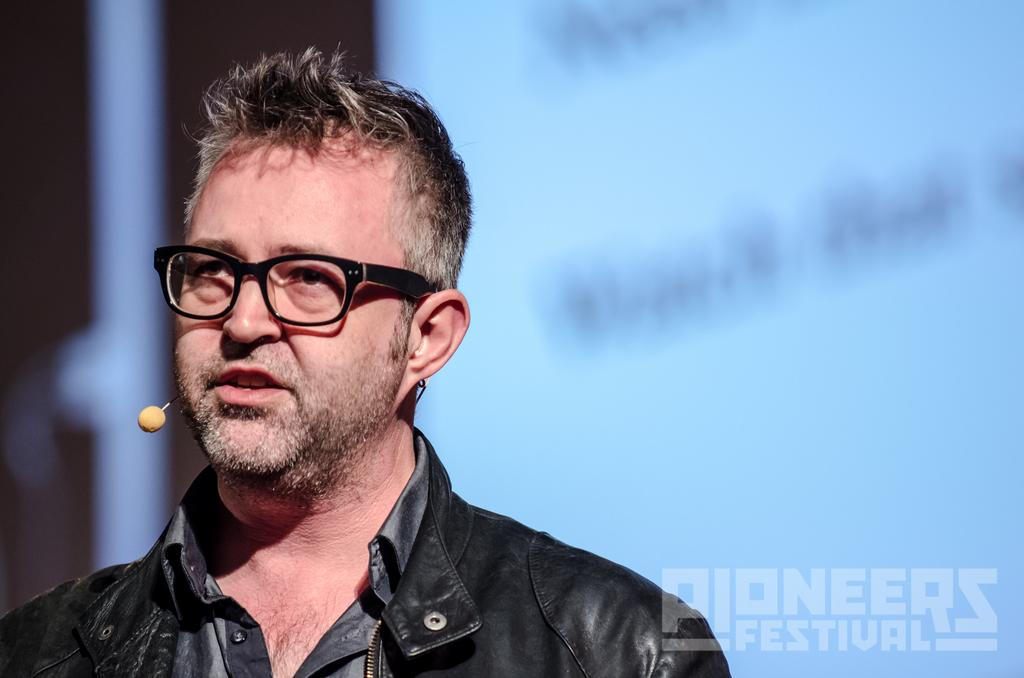What is the main subject of the image? There is a man standing in the image. Can you describe the man's appearance? The man is wearing black glasses. What object is present in the image that is typically used for amplifying sound? There is a microphone in the image. What color is the background of the image? The background of the image is blue. What type of necklace is the man wearing in the image? There is no necklace visible in the image; the man is wearing black glasses. What power source is used to operate the microphone in the image? The image does not provide information about the power source for the microphone. 